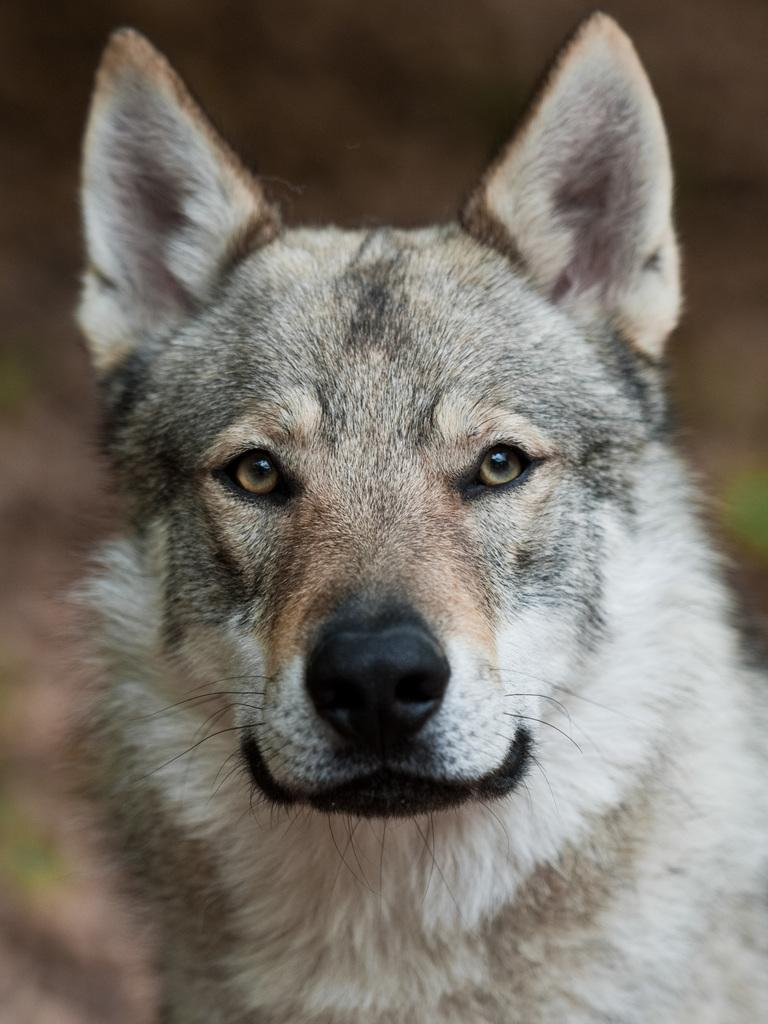What type of animal is in the image? There is a dog in the image. Can you describe the color pattern of the dog? The dog is brown, black, and white in color. What is the background of the image like? The background of the image is blurry. What type of step can be seen in the image? There is no step present in the image; it features a dog with a specific color pattern and a blurry background. How many teeth can be seen in the image? There are no teeth visible in the image, as it features a dog and not a person or animal with visible teeth. 